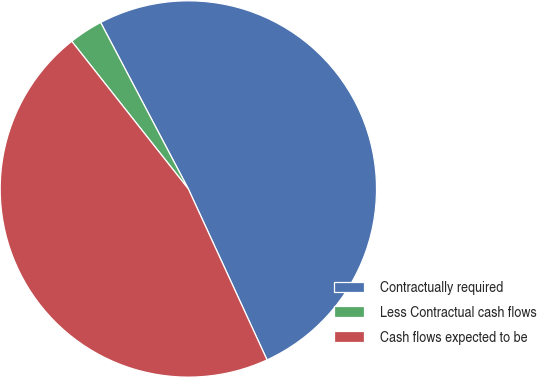Convert chart to OTSL. <chart><loc_0><loc_0><loc_500><loc_500><pie_chart><fcel>Contractually required<fcel>Less Contractual cash flows<fcel>Cash flows expected to be<nl><fcel>50.85%<fcel>2.92%<fcel>46.23%<nl></chart> 